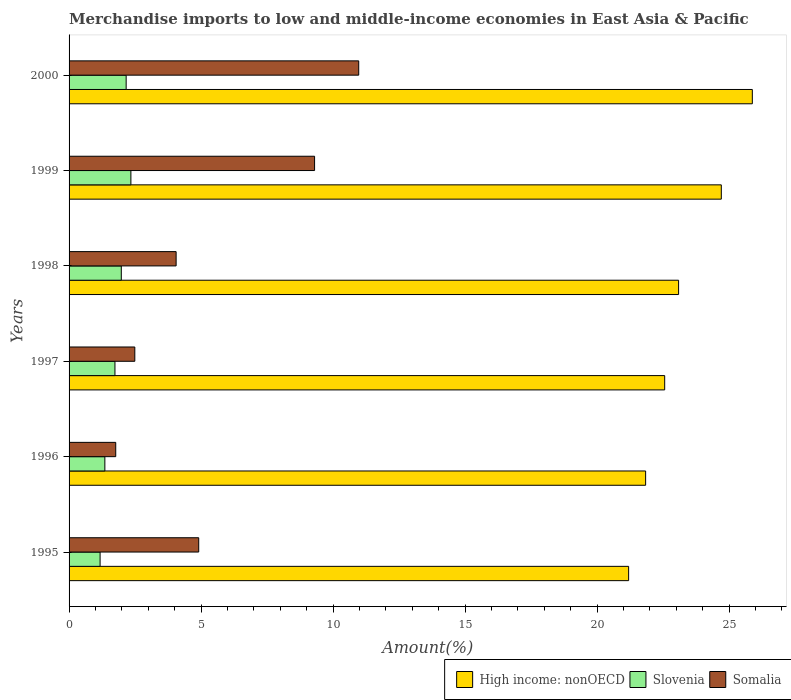How many groups of bars are there?
Make the answer very short. 6. Are the number of bars per tick equal to the number of legend labels?
Your response must be concise. Yes. Are the number of bars on each tick of the Y-axis equal?
Provide a short and direct response. Yes. What is the label of the 6th group of bars from the top?
Provide a short and direct response. 1995. What is the percentage of amount earned from merchandise imports in Slovenia in 2000?
Your answer should be very brief. 2.16. Across all years, what is the maximum percentage of amount earned from merchandise imports in Somalia?
Offer a very short reply. 10.97. Across all years, what is the minimum percentage of amount earned from merchandise imports in High income: nonOECD?
Provide a short and direct response. 21.19. In which year was the percentage of amount earned from merchandise imports in Somalia maximum?
Keep it short and to the point. 2000. What is the total percentage of amount earned from merchandise imports in High income: nonOECD in the graph?
Keep it short and to the point. 139.25. What is the difference between the percentage of amount earned from merchandise imports in Somalia in 1998 and that in 2000?
Provide a succinct answer. -6.92. What is the difference between the percentage of amount earned from merchandise imports in High income: nonOECD in 1995 and the percentage of amount earned from merchandise imports in Somalia in 1999?
Your answer should be very brief. 11.89. What is the average percentage of amount earned from merchandise imports in Slovenia per year?
Your answer should be compact. 1.79. In the year 1997, what is the difference between the percentage of amount earned from merchandise imports in High income: nonOECD and percentage of amount earned from merchandise imports in Slovenia?
Keep it short and to the point. 20.82. In how many years, is the percentage of amount earned from merchandise imports in Somalia greater than 8 %?
Provide a short and direct response. 2. What is the ratio of the percentage of amount earned from merchandise imports in Somalia in 1995 to that in 2000?
Provide a short and direct response. 0.45. Is the percentage of amount earned from merchandise imports in Slovenia in 1998 less than that in 1999?
Give a very brief answer. Yes. Is the difference between the percentage of amount earned from merchandise imports in High income: nonOECD in 1998 and 1999 greater than the difference between the percentage of amount earned from merchandise imports in Slovenia in 1998 and 1999?
Your response must be concise. No. What is the difference between the highest and the second highest percentage of amount earned from merchandise imports in High income: nonOECD?
Ensure brevity in your answer.  1.17. What is the difference between the highest and the lowest percentage of amount earned from merchandise imports in Slovenia?
Make the answer very short. 1.17. In how many years, is the percentage of amount earned from merchandise imports in Somalia greater than the average percentage of amount earned from merchandise imports in Somalia taken over all years?
Your answer should be compact. 2. Is the sum of the percentage of amount earned from merchandise imports in Somalia in 1995 and 1996 greater than the maximum percentage of amount earned from merchandise imports in High income: nonOECD across all years?
Keep it short and to the point. No. What does the 2nd bar from the top in 1995 represents?
Provide a succinct answer. Slovenia. What does the 2nd bar from the bottom in 1997 represents?
Make the answer very short. Slovenia. Are all the bars in the graph horizontal?
Keep it short and to the point. Yes. Are the values on the major ticks of X-axis written in scientific E-notation?
Give a very brief answer. No. Does the graph contain any zero values?
Your answer should be very brief. No. Where does the legend appear in the graph?
Offer a terse response. Bottom right. How are the legend labels stacked?
Give a very brief answer. Horizontal. What is the title of the graph?
Keep it short and to the point. Merchandise imports to low and middle-income economies in East Asia & Pacific. What is the label or title of the X-axis?
Give a very brief answer. Amount(%). What is the Amount(%) in High income: nonOECD in 1995?
Your answer should be very brief. 21.19. What is the Amount(%) of Slovenia in 1995?
Ensure brevity in your answer.  1.17. What is the Amount(%) of Somalia in 1995?
Give a very brief answer. 4.91. What is the Amount(%) of High income: nonOECD in 1996?
Offer a terse response. 21.84. What is the Amount(%) of Slovenia in 1996?
Offer a very short reply. 1.36. What is the Amount(%) in Somalia in 1996?
Offer a terse response. 1.77. What is the Amount(%) of High income: nonOECD in 1997?
Keep it short and to the point. 22.56. What is the Amount(%) in Slovenia in 1997?
Keep it short and to the point. 1.74. What is the Amount(%) in Somalia in 1997?
Your answer should be very brief. 2.49. What is the Amount(%) in High income: nonOECD in 1998?
Offer a very short reply. 23.08. What is the Amount(%) in Slovenia in 1998?
Keep it short and to the point. 1.98. What is the Amount(%) of Somalia in 1998?
Your response must be concise. 4.05. What is the Amount(%) of High income: nonOECD in 1999?
Offer a terse response. 24.7. What is the Amount(%) in Slovenia in 1999?
Keep it short and to the point. 2.34. What is the Amount(%) in Somalia in 1999?
Ensure brevity in your answer.  9.3. What is the Amount(%) of High income: nonOECD in 2000?
Offer a terse response. 25.88. What is the Amount(%) in Slovenia in 2000?
Your answer should be very brief. 2.16. What is the Amount(%) in Somalia in 2000?
Offer a terse response. 10.97. Across all years, what is the maximum Amount(%) of High income: nonOECD?
Offer a terse response. 25.88. Across all years, what is the maximum Amount(%) of Slovenia?
Keep it short and to the point. 2.34. Across all years, what is the maximum Amount(%) in Somalia?
Keep it short and to the point. 10.97. Across all years, what is the minimum Amount(%) of High income: nonOECD?
Ensure brevity in your answer.  21.19. Across all years, what is the minimum Amount(%) of Slovenia?
Offer a terse response. 1.17. Across all years, what is the minimum Amount(%) in Somalia?
Provide a short and direct response. 1.77. What is the total Amount(%) in High income: nonOECD in the graph?
Ensure brevity in your answer.  139.25. What is the total Amount(%) of Slovenia in the graph?
Offer a terse response. 10.75. What is the total Amount(%) of Somalia in the graph?
Your response must be concise. 33.49. What is the difference between the Amount(%) in High income: nonOECD in 1995 and that in 1996?
Make the answer very short. -0.64. What is the difference between the Amount(%) in Slovenia in 1995 and that in 1996?
Provide a short and direct response. -0.18. What is the difference between the Amount(%) of Somalia in 1995 and that in 1996?
Offer a terse response. 3.14. What is the difference between the Amount(%) of High income: nonOECD in 1995 and that in 1997?
Make the answer very short. -1.37. What is the difference between the Amount(%) of Slovenia in 1995 and that in 1997?
Give a very brief answer. -0.56. What is the difference between the Amount(%) in Somalia in 1995 and that in 1997?
Your answer should be very brief. 2.42. What is the difference between the Amount(%) in High income: nonOECD in 1995 and that in 1998?
Offer a very short reply. -1.89. What is the difference between the Amount(%) in Slovenia in 1995 and that in 1998?
Your answer should be very brief. -0.8. What is the difference between the Amount(%) in Somalia in 1995 and that in 1998?
Make the answer very short. 0.86. What is the difference between the Amount(%) of High income: nonOECD in 1995 and that in 1999?
Your answer should be very brief. -3.51. What is the difference between the Amount(%) in Slovenia in 1995 and that in 1999?
Make the answer very short. -1.17. What is the difference between the Amount(%) of Somalia in 1995 and that in 1999?
Your answer should be very brief. -4.39. What is the difference between the Amount(%) of High income: nonOECD in 1995 and that in 2000?
Your response must be concise. -4.68. What is the difference between the Amount(%) of Slovenia in 1995 and that in 2000?
Ensure brevity in your answer.  -0.99. What is the difference between the Amount(%) in Somalia in 1995 and that in 2000?
Offer a very short reply. -6.06. What is the difference between the Amount(%) of High income: nonOECD in 1996 and that in 1997?
Your response must be concise. -0.72. What is the difference between the Amount(%) of Slovenia in 1996 and that in 1997?
Provide a succinct answer. -0.38. What is the difference between the Amount(%) of Somalia in 1996 and that in 1997?
Provide a succinct answer. -0.72. What is the difference between the Amount(%) in High income: nonOECD in 1996 and that in 1998?
Ensure brevity in your answer.  -1.25. What is the difference between the Amount(%) of Slovenia in 1996 and that in 1998?
Make the answer very short. -0.62. What is the difference between the Amount(%) of Somalia in 1996 and that in 1998?
Provide a succinct answer. -2.29. What is the difference between the Amount(%) of High income: nonOECD in 1996 and that in 1999?
Ensure brevity in your answer.  -2.87. What is the difference between the Amount(%) in Slovenia in 1996 and that in 1999?
Your response must be concise. -0.99. What is the difference between the Amount(%) of Somalia in 1996 and that in 1999?
Offer a terse response. -7.53. What is the difference between the Amount(%) in High income: nonOECD in 1996 and that in 2000?
Give a very brief answer. -4.04. What is the difference between the Amount(%) of Slovenia in 1996 and that in 2000?
Your answer should be very brief. -0.81. What is the difference between the Amount(%) in Somalia in 1996 and that in 2000?
Provide a succinct answer. -9.2. What is the difference between the Amount(%) of High income: nonOECD in 1997 and that in 1998?
Give a very brief answer. -0.53. What is the difference between the Amount(%) in Slovenia in 1997 and that in 1998?
Offer a terse response. -0.24. What is the difference between the Amount(%) of Somalia in 1997 and that in 1998?
Your answer should be very brief. -1.56. What is the difference between the Amount(%) of High income: nonOECD in 1997 and that in 1999?
Give a very brief answer. -2.14. What is the difference between the Amount(%) of Slovenia in 1997 and that in 1999?
Provide a short and direct response. -0.6. What is the difference between the Amount(%) of Somalia in 1997 and that in 1999?
Your answer should be very brief. -6.81. What is the difference between the Amount(%) in High income: nonOECD in 1997 and that in 2000?
Keep it short and to the point. -3.32. What is the difference between the Amount(%) in Slovenia in 1997 and that in 2000?
Provide a short and direct response. -0.42. What is the difference between the Amount(%) of Somalia in 1997 and that in 2000?
Your answer should be compact. -8.48. What is the difference between the Amount(%) in High income: nonOECD in 1998 and that in 1999?
Your response must be concise. -1.62. What is the difference between the Amount(%) in Slovenia in 1998 and that in 1999?
Offer a very short reply. -0.36. What is the difference between the Amount(%) in Somalia in 1998 and that in 1999?
Ensure brevity in your answer.  -5.24. What is the difference between the Amount(%) of High income: nonOECD in 1998 and that in 2000?
Your response must be concise. -2.79. What is the difference between the Amount(%) in Slovenia in 1998 and that in 2000?
Your response must be concise. -0.18. What is the difference between the Amount(%) of Somalia in 1998 and that in 2000?
Provide a succinct answer. -6.92. What is the difference between the Amount(%) in High income: nonOECD in 1999 and that in 2000?
Ensure brevity in your answer.  -1.17. What is the difference between the Amount(%) in Slovenia in 1999 and that in 2000?
Offer a terse response. 0.18. What is the difference between the Amount(%) of Somalia in 1999 and that in 2000?
Offer a very short reply. -1.67. What is the difference between the Amount(%) of High income: nonOECD in 1995 and the Amount(%) of Slovenia in 1996?
Your response must be concise. 19.84. What is the difference between the Amount(%) of High income: nonOECD in 1995 and the Amount(%) of Somalia in 1996?
Your response must be concise. 19.43. What is the difference between the Amount(%) in Slovenia in 1995 and the Amount(%) in Somalia in 1996?
Provide a short and direct response. -0.59. What is the difference between the Amount(%) in High income: nonOECD in 1995 and the Amount(%) in Slovenia in 1997?
Offer a terse response. 19.45. What is the difference between the Amount(%) of High income: nonOECD in 1995 and the Amount(%) of Somalia in 1997?
Provide a short and direct response. 18.7. What is the difference between the Amount(%) in Slovenia in 1995 and the Amount(%) in Somalia in 1997?
Make the answer very short. -1.32. What is the difference between the Amount(%) in High income: nonOECD in 1995 and the Amount(%) in Slovenia in 1998?
Your answer should be compact. 19.21. What is the difference between the Amount(%) of High income: nonOECD in 1995 and the Amount(%) of Somalia in 1998?
Your answer should be compact. 17.14. What is the difference between the Amount(%) in Slovenia in 1995 and the Amount(%) in Somalia in 1998?
Offer a very short reply. -2.88. What is the difference between the Amount(%) of High income: nonOECD in 1995 and the Amount(%) of Slovenia in 1999?
Your answer should be compact. 18.85. What is the difference between the Amount(%) in High income: nonOECD in 1995 and the Amount(%) in Somalia in 1999?
Your answer should be compact. 11.89. What is the difference between the Amount(%) in Slovenia in 1995 and the Amount(%) in Somalia in 1999?
Offer a very short reply. -8.12. What is the difference between the Amount(%) in High income: nonOECD in 1995 and the Amount(%) in Slovenia in 2000?
Make the answer very short. 19.03. What is the difference between the Amount(%) in High income: nonOECD in 1995 and the Amount(%) in Somalia in 2000?
Your answer should be very brief. 10.22. What is the difference between the Amount(%) in Slovenia in 1995 and the Amount(%) in Somalia in 2000?
Provide a short and direct response. -9.8. What is the difference between the Amount(%) of High income: nonOECD in 1996 and the Amount(%) of Slovenia in 1997?
Keep it short and to the point. 20.1. What is the difference between the Amount(%) of High income: nonOECD in 1996 and the Amount(%) of Somalia in 1997?
Keep it short and to the point. 19.35. What is the difference between the Amount(%) of Slovenia in 1996 and the Amount(%) of Somalia in 1997?
Make the answer very short. -1.13. What is the difference between the Amount(%) of High income: nonOECD in 1996 and the Amount(%) of Slovenia in 1998?
Make the answer very short. 19.86. What is the difference between the Amount(%) of High income: nonOECD in 1996 and the Amount(%) of Somalia in 1998?
Your response must be concise. 17.78. What is the difference between the Amount(%) in Slovenia in 1996 and the Amount(%) in Somalia in 1998?
Your response must be concise. -2.7. What is the difference between the Amount(%) of High income: nonOECD in 1996 and the Amount(%) of Slovenia in 1999?
Your response must be concise. 19.5. What is the difference between the Amount(%) of High income: nonOECD in 1996 and the Amount(%) of Somalia in 1999?
Offer a very short reply. 12.54. What is the difference between the Amount(%) in Slovenia in 1996 and the Amount(%) in Somalia in 1999?
Offer a very short reply. -7.94. What is the difference between the Amount(%) in High income: nonOECD in 1996 and the Amount(%) in Slovenia in 2000?
Your answer should be compact. 19.67. What is the difference between the Amount(%) of High income: nonOECD in 1996 and the Amount(%) of Somalia in 2000?
Your answer should be very brief. 10.87. What is the difference between the Amount(%) of Slovenia in 1996 and the Amount(%) of Somalia in 2000?
Provide a short and direct response. -9.61. What is the difference between the Amount(%) of High income: nonOECD in 1997 and the Amount(%) of Slovenia in 1998?
Offer a terse response. 20.58. What is the difference between the Amount(%) in High income: nonOECD in 1997 and the Amount(%) in Somalia in 1998?
Your answer should be very brief. 18.5. What is the difference between the Amount(%) of Slovenia in 1997 and the Amount(%) of Somalia in 1998?
Keep it short and to the point. -2.32. What is the difference between the Amount(%) of High income: nonOECD in 1997 and the Amount(%) of Slovenia in 1999?
Ensure brevity in your answer.  20.22. What is the difference between the Amount(%) in High income: nonOECD in 1997 and the Amount(%) in Somalia in 1999?
Your response must be concise. 13.26. What is the difference between the Amount(%) of Slovenia in 1997 and the Amount(%) of Somalia in 1999?
Make the answer very short. -7.56. What is the difference between the Amount(%) in High income: nonOECD in 1997 and the Amount(%) in Slovenia in 2000?
Provide a succinct answer. 20.4. What is the difference between the Amount(%) in High income: nonOECD in 1997 and the Amount(%) in Somalia in 2000?
Offer a terse response. 11.59. What is the difference between the Amount(%) of Slovenia in 1997 and the Amount(%) of Somalia in 2000?
Ensure brevity in your answer.  -9.23. What is the difference between the Amount(%) in High income: nonOECD in 1998 and the Amount(%) in Slovenia in 1999?
Make the answer very short. 20.74. What is the difference between the Amount(%) of High income: nonOECD in 1998 and the Amount(%) of Somalia in 1999?
Make the answer very short. 13.79. What is the difference between the Amount(%) of Slovenia in 1998 and the Amount(%) of Somalia in 1999?
Provide a succinct answer. -7.32. What is the difference between the Amount(%) in High income: nonOECD in 1998 and the Amount(%) in Slovenia in 2000?
Your answer should be compact. 20.92. What is the difference between the Amount(%) in High income: nonOECD in 1998 and the Amount(%) in Somalia in 2000?
Offer a very short reply. 12.11. What is the difference between the Amount(%) of Slovenia in 1998 and the Amount(%) of Somalia in 2000?
Offer a terse response. -8.99. What is the difference between the Amount(%) of High income: nonOECD in 1999 and the Amount(%) of Slovenia in 2000?
Keep it short and to the point. 22.54. What is the difference between the Amount(%) of High income: nonOECD in 1999 and the Amount(%) of Somalia in 2000?
Your answer should be compact. 13.73. What is the difference between the Amount(%) in Slovenia in 1999 and the Amount(%) in Somalia in 2000?
Keep it short and to the point. -8.63. What is the average Amount(%) in High income: nonOECD per year?
Give a very brief answer. 23.21. What is the average Amount(%) of Slovenia per year?
Ensure brevity in your answer.  1.79. What is the average Amount(%) in Somalia per year?
Make the answer very short. 5.58. In the year 1995, what is the difference between the Amount(%) of High income: nonOECD and Amount(%) of Slovenia?
Provide a succinct answer. 20.02. In the year 1995, what is the difference between the Amount(%) of High income: nonOECD and Amount(%) of Somalia?
Make the answer very short. 16.28. In the year 1995, what is the difference between the Amount(%) of Slovenia and Amount(%) of Somalia?
Offer a terse response. -3.74. In the year 1996, what is the difference between the Amount(%) in High income: nonOECD and Amount(%) in Slovenia?
Provide a short and direct response. 20.48. In the year 1996, what is the difference between the Amount(%) of High income: nonOECD and Amount(%) of Somalia?
Provide a succinct answer. 20.07. In the year 1996, what is the difference between the Amount(%) of Slovenia and Amount(%) of Somalia?
Provide a succinct answer. -0.41. In the year 1997, what is the difference between the Amount(%) of High income: nonOECD and Amount(%) of Slovenia?
Offer a very short reply. 20.82. In the year 1997, what is the difference between the Amount(%) of High income: nonOECD and Amount(%) of Somalia?
Make the answer very short. 20.07. In the year 1997, what is the difference between the Amount(%) of Slovenia and Amount(%) of Somalia?
Provide a succinct answer. -0.75. In the year 1998, what is the difference between the Amount(%) of High income: nonOECD and Amount(%) of Slovenia?
Offer a terse response. 21.11. In the year 1998, what is the difference between the Amount(%) in High income: nonOECD and Amount(%) in Somalia?
Offer a very short reply. 19.03. In the year 1998, what is the difference between the Amount(%) of Slovenia and Amount(%) of Somalia?
Your answer should be compact. -2.08. In the year 1999, what is the difference between the Amount(%) of High income: nonOECD and Amount(%) of Slovenia?
Give a very brief answer. 22.36. In the year 1999, what is the difference between the Amount(%) in High income: nonOECD and Amount(%) in Somalia?
Your response must be concise. 15.4. In the year 1999, what is the difference between the Amount(%) of Slovenia and Amount(%) of Somalia?
Provide a succinct answer. -6.96. In the year 2000, what is the difference between the Amount(%) of High income: nonOECD and Amount(%) of Slovenia?
Offer a very short reply. 23.72. In the year 2000, what is the difference between the Amount(%) of High income: nonOECD and Amount(%) of Somalia?
Make the answer very short. 14.91. In the year 2000, what is the difference between the Amount(%) of Slovenia and Amount(%) of Somalia?
Your answer should be very brief. -8.81. What is the ratio of the Amount(%) of High income: nonOECD in 1995 to that in 1996?
Offer a terse response. 0.97. What is the ratio of the Amount(%) of Slovenia in 1995 to that in 1996?
Your answer should be very brief. 0.87. What is the ratio of the Amount(%) of Somalia in 1995 to that in 1996?
Offer a terse response. 2.78. What is the ratio of the Amount(%) in High income: nonOECD in 1995 to that in 1997?
Offer a terse response. 0.94. What is the ratio of the Amount(%) in Slovenia in 1995 to that in 1997?
Offer a very short reply. 0.68. What is the ratio of the Amount(%) of Somalia in 1995 to that in 1997?
Keep it short and to the point. 1.97. What is the ratio of the Amount(%) of High income: nonOECD in 1995 to that in 1998?
Provide a succinct answer. 0.92. What is the ratio of the Amount(%) of Slovenia in 1995 to that in 1998?
Provide a short and direct response. 0.59. What is the ratio of the Amount(%) in Somalia in 1995 to that in 1998?
Make the answer very short. 1.21. What is the ratio of the Amount(%) of High income: nonOECD in 1995 to that in 1999?
Keep it short and to the point. 0.86. What is the ratio of the Amount(%) in Slovenia in 1995 to that in 1999?
Your answer should be very brief. 0.5. What is the ratio of the Amount(%) in Somalia in 1995 to that in 1999?
Provide a succinct answer. 0.53. What is the ratio of the Amount(%) in High income: nonOECD in 1995 to that in 2000?
Provide a succinct answer. 0.82. What is the ratio of the Amount(%) of Slovenia in 1995 to that in 2000?
Keep it short and to the point. 0.54. What is the ratio of the Amount(%) of Somalia in 1995 to that in 2000?
Offer a very short reply. 0.45. What is the ratio of the Amount(%) of Slovenia in 1996 to that in 1997?
Provide a short and direct response. 0.78. What is the ratio of the Amount(%) in Somalia in 1996 to that in 1997?
Make the answer very short. 0.71. What is the ratio of the Amount(%) in High income: nonOECD in 1996 to that in 1998?
Give a very brief answer. 0.95. What is the ratio of the Amount(%) of Slovenia in 1996 to that in 1998?
Provide a succinct answer. 0.69. What is the ratio of the Amount(%) of Somalia in 1996 to that in 1998?
Your response must be concise. 0.44. What is the ratio of the Amount(%) of High income: nonOECD in 1996 to that in 1999?
Your response must be concise. 0.88. What is the ratio of the Amount(%) of Slovenia in 1996 to that in 1999?
Give a very brief answer. 0.58. What is the ratio of the Amount(%) of Somalia in 1996 to that in 1999?
Offer a terse response. 0.19. What is the ratio of the Amount(%) in High income: nonOECD in 1996 to that in 2000?
Your answer should be compact. 0.84. What is the ratio of the Amount(%) in Slovenia in 1996 to that in 2000?
Ensure brevity in your answer.  0.63. What is the ratio of the Amount(%) in Somalia in 1996 to that in 2000?
Give a very brief answer. 0.16. What is the ratio of the Amount(%) in High income: nonOECD in 1997 to that in 1998?
Provide a short and direct response. 0.98. What is the ratio of the Amount(%) in Slovenia in 1997 to that in 1998?
Ensure brevity in your answer.  0.88. What is the ratio of the Amount(%) of Somalia in 1997 to that in 1998?
Your answer should be compact. 0.61. What is the ratio of the Amount(%) of High income: nonOECD in 1997 to that in 1999?
Your answer should be very brief. 0.91. What is the ratio of the Amount(%) in Slovenia in 1997 to that in 1999?
Offer a terse response. 0.74. What is the ratio of the Amount(%) of Somalia in 1997 to that in 1999?
Your answer should be very brief. 0.27. What is the ratio of the Amount(%) of High income: nonOECD in 1997 to that in 2000?
Your response must be concise. 0.87. What is the ratio of the Amount(%) in Slovenia in 1997 to that in 2000?
Your answer should be compact. 0.8. What is the ratio of the Amount(%) in Somalia in 1997 to that in 2000?
Your response must be concise. 0.23. What is the ratio of the Amount(%) of High income: nonOECD in 1998 to that in 1999?
Your answer should be very brief. 0.93. What is the ratio of the Amount(%) in Slovenia in 1998 to that in 1999?
Provide a succinct answer. 0.84. What is the ratio of the Amount(%) of Somalia in 1998 to that in 1999?
Your response must be concise. 0.44. What is the ratio of the Amount(%) in High income: nonOECD in 1998 to that in 2000?
Your answer should be very brief. 0.89. What is the ratio of the Amount(%) of Slovenia in 1998 to that in 2000?
Offer a very short reply. 0.92. What is the ratio of the Amount(%) of Somalia in 1998 to that in 2000?
Offer a very short reply. 0.37. What is the ratio of the Amount(%) in High income: nonOECD in 1999 to that in 2000?
Provide a succinct answer. 0.95. What is the ratio of the Amount(%) in Slovenia in 1999 to that in 2000?
Your answer should be very brief. 1.08. What is the ratio of the Amount(%) of Somalia in 1999 to that in 2000?
Provide a succinct answer. 0.85. What is the difference between the highest and the second highest Amount(%) in High income: nonOECD?
Keep it short and to the point. 1.17. What is the difference between the highest and the second highest Amount(%) in Slovenia?
Provide a short and direct response. 0.18. What is the difference between the highest and the second highest Amount(%) of Somalia?
Make the answer very short. 1.67. What is the difference between the highest and the lowest Amount(%) in High income: nonOECD?
Offer a very short reply. 4.68. What is the difference between the highest and the lowest Amount(%) of Slovenia?
Your response must be concise. 1.17. What is the difference between the highest and the lowest Amount(%) of Somalia?
Your answer should be very brief. 9.2. 